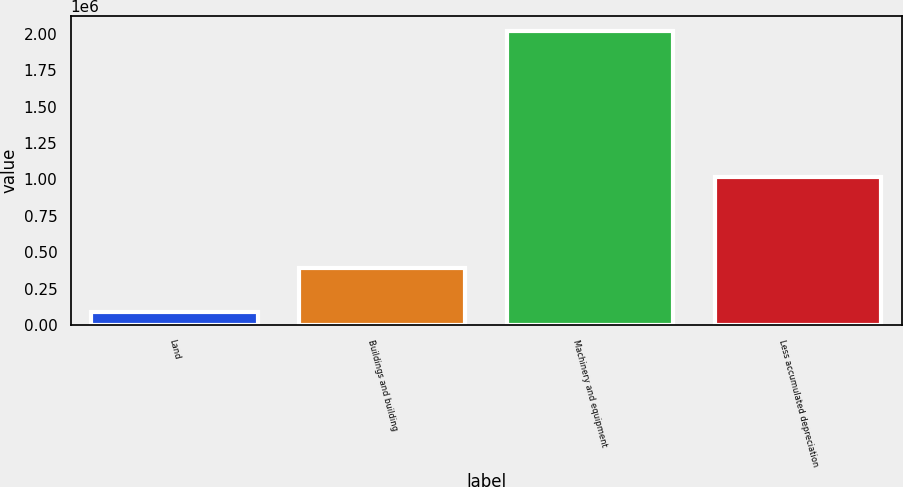<chart> <loc_0><loc_0><loc_500><loc_500><bar_chart><fcel>Land<fcel>Buildings and building<fcel>Machinery and equipment<fcel>Less accumulated depreciation<nl><fcel>87237<fcel>393580<fcel>2.0232e+06<fcel>1.01882e+06<nl></chart> 